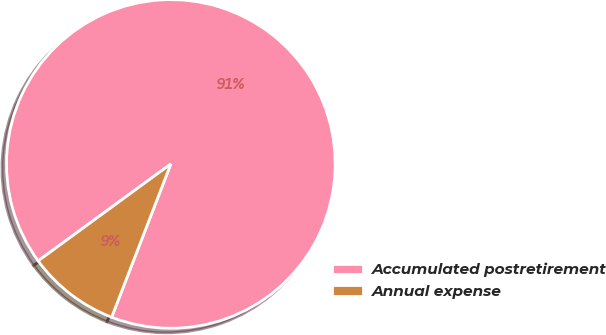Convert chart. <chart><loc_0><loc_0><loc_500><loc_500><pie_chart><fcel>Accumulated postretirement<fcel>Annual expense<nl><fcel>90.91%<fcel>9.09%<nl></chart> 